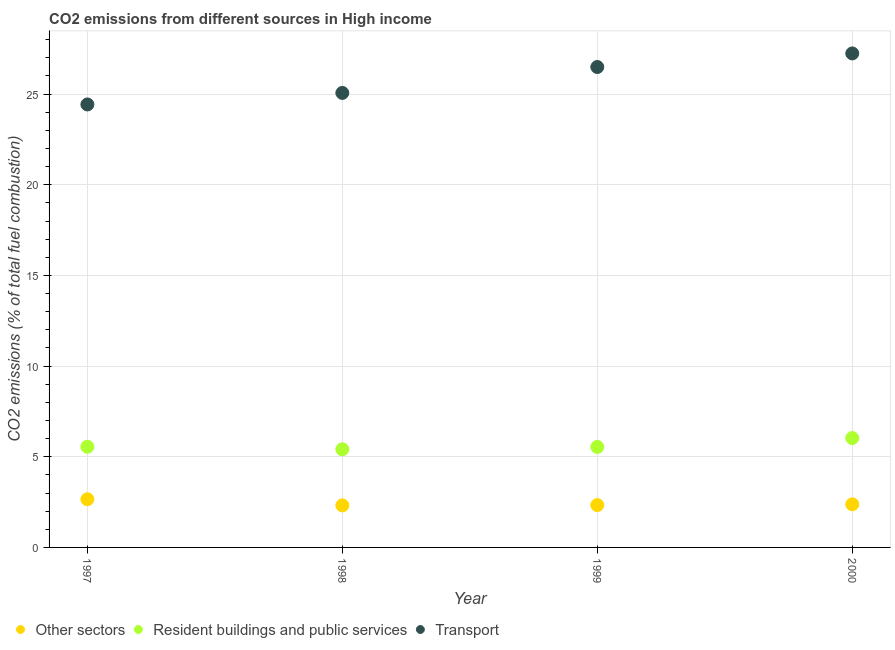Is the number of dotlines equal to the number of legend labels?
Your answer should be compact. Yes. What is the percentage of co2 emissions from transport in 1999?
Keep it short and to the point. 26.49. Across all years, what is the maximum percentage of co2 emissions from other sectors?
Give a very brief answer. 2.66. Across all years, what is the minimum percentage of co2 emissions from other sectors?
Give a very brief answer. 2.32. In which year was the percentage of co2 emissions from resident buildings and public services maximum?
Your answer should be compact. 2000. What is the total percentage of co2 emissions from resident buildings and public services in the graph?
Give a very brief answer. 22.53. What is the difference between the percentage of co2 emissions from resident buildings and public services in 1997 and that in 2000?
Make the answer very short. -0.48. What is the difference between the percentage of co2 emissions from other sectors in 1999 and the percentage of co2 emissions from transport in 1998?
Make the answer very short. -22.73. What is the average percentage of co2 emissions from resident buildings and public services per year?
Your answer should be compact. 5.63. In the year 1999, what is the difference between the percentage of co2 emissions from resident buildings and public services and percentage of co2 emissions from transport?
Provide a succinct answer. -20.95. What is the ratio of the percentage of co2 emissions from transport in 1997 to that in 1998?
Make the answer very short. 0.97. Is the percentage of co2 emissions from resident buildings and public services in 1998 less than that in 2000?
Provide a short and direct response. Yes. Is the difference between the percentage of co2 emissions from other sectors in 1998 and 1999 greater than the difference between the percentage of co2 emissions from resident buildings and public services in 1998 and 1999?
Give a very brief answer. Yes. What is the difference between the highest and the second highest percentage of co2 emissions from other sectors?
Provide a short and direct response. 0.28. What is the difference between the highest and the lowest percentage of co2 emissions from resident buildings and public services?
Ensure brevity in your answer.  0.62. Is it the case that in every year, the sum of the percentage of co2 emissions from other sectors and percentage of co2 emissions from resident buildings and public services is greater than the percentage of co2 emissions from transport?
Provide a succinct answer. No. Is the percentage of co2 emissions from transport strictly greater than the percentage of co2 emissions from resident buildings and public services over the years?
Offer a very short reply. Yes. How many years are there in the graph?
Your answer should be compact. 4. What is the difference between two consecutive major ticks on the Y-axis?
Provide a succinct answer. 5. Does the graph contain any zero values?
Your answer should be very brief. No. Does the graph contain grids?
Make the answer very short. Yes. How many legend labels are there?
Provide a succinct answer. 3. How are the legend labels stacked?
Offer a very short reply. Horizontal. What is the title of the graph?
Your answer should be very brief. CO2 emissions from different sources in High income. Does "Refusal of sex" appear as one of the legend labels in the graph?
Your response must be concise. No. What is the label or title of the Y-axis?
Provide a succinct answer. CO2 emissions (% of total fuel combustion). What is the CO2 emissions (% of total fuel combustion) in Other sectors in 1997?
Ensure brevity in your answer.  2.66. What is the CO2 emissions (% of total fuel combustion) in Resident buildings and public services in 1997?
Offer a terse response. 5.55. What is the CO2 emissions (% of total fuel combustion) in Transport in 1997?
Provide a short and direct response. 24.43. What is the CO2 emissions (% of total fuel combustion) of Other sectors in 1998?
Give a very brief answer. 2.32. What is the CO2 emissions (% of total fuel combustion) in Resident buildings and public services in 1998?
Offer a terse response. 5.41. What is the CO2 emissions (% of total fuel combustion) in Transport in 1998?
Provide a succinct answer. 25.06. What is the CO2 emissions (% of total fuel combustion) in Other sectors in 1999?
Offer a terse response. 2.33. What is the CO2 emissions (% of total fuel combustion) of Resident buildings and public services in 1999?
Ensure brevity in your answer.  5.54. What is the CO2 emissions (% of total fuel combustion) in Transport in 1999?
Keep it short and to the point. 26.49. What is the CO2 emissions (% of total fuel combustion) in Other sectors in 2000?
Your answer should be compact. 2.38. What is the CO2 emissions (% of total fuel combustion) in Resident buildings and public services in 2000?
Keep it short and to the point. 6.03. What is the CO2 emissions (% of total fuel combustion) of Transport in 2000?
Offer a terse response. 27.24. Across all years, what is the maximum CO2 emissions (% of total fuel combustion) of Other sectors?
Ensure brevity in your answer.  2.66. Across all years, what is the maximum CO2 emissions (% of total fuel combustion) in Resident buildings and public services?
Offer a very short reply. 6.03. Across all years, what is the maximum CO2 emissions (% of total fuel combustion) in Transport?
Provide a short and direct response. 27.24. Across all years, what is the minimum CO2 emissions (% of total fuel combustion) in Other sectors?
Provide a succinct answer. 2.32. Across all years, what is the minimum CO2 emissions (% of total fuel combustion) of Resident buildings and public services?
Give a very brief answer. 5.41. Across all years, what is the minimum CO2 emissions (% of total fuel combustion) of Transport?
Provide a short and direct response. 24.43. What is the total CO2 emissions (% of total fuel combustion) in Other sectors in the graph?
Keep it short and to the point. 9.69. What is the total CO2 emissions (% of total fuel combustion) in Resident buildings and public services in the graph?
Provide a short and direct response. 22.53. What is the total CO2 emissions (% of total fuel combustion) of Transport in the graph?
Provide a succinct answer. 103.22. What is the difference between the CO2 emissions (% of total fuel combustion) of Other sectors in 1997 and that in 1998?
Make the answer very short. 0.34. What is the difference between the CO2 emissions (% of total fuel combustion) in Resident buildings and public services in 1997 and that in 1998?
Provide a succinct answer. 0.14. What is the difference between the CO2 emissions (% of total fuel combustion) in Transport in 1997 and that in 1998?
Offer a terse response. -0.64. What is the difference between the CO2 emissions (% of total fuel combustion) of Other sectors in 1997 and that in 1999?
Offer a terse response. 0.32. What is the difference between the CO2 emissions (% of total fuel combustion) of Resident buildings and public services in 1997 and that in 1999?
Make the answer very short. 0.01. What is the difference between the CO2 emissions (% of total fuel combustion) in Transport in 1997 and that in 1999?
Your answer should be compact. -2.06. What is the difference between the CO2 emissions (% of total fuel combustion) of Other sectors in 1997 and that in 2000?
Keep it short and to the point. 0.28. What is the difference between the CO2 emissions (% of total fuel combustion) in Resident buildings and public services in 1997 and that in 2000?
Keep it short and to the point. -0.48. What is the difference between the CO2 emissions (% of total fuel combustion) of Transport in 1997 and that in 2000?
Give a very brief answer. -2.81. What is the difference between the CO2 emissions (% of total fuel combustion) of Other sectors in 1998 and that in 1999?
Your answer should be very brief. -0.02. What is the difference between the CO2 emissions (% of total fuel combustion) in Resident buildings and public services in 1998 and that in 1999?
Keep it short and to the point. -0.13. What is the difference between the CO2 emissions (% of total fuel combustion) in Transport in 1998 and that in 1999?
Offer a very short reply. -1.43. What is the difference between the CO2 emissions (% of total fuel combustion) in Other sectors in 1998 and that in 2000?
Make the answer very short. -0.06. What is the difference between the CO2 emissions (% of total fuel combustion) in Resident buildings and public services in 1998 and that in 2000?
Ensure brevity in your answer.  -0.62. What is the difference between the CO2 emissions (% of total fuel combustion) in Transport in 1998 and that in 2000?
Keep it short and to the point. -2.18. What is the difference between the CO2 emissions (% of total fuel combustion) in Other sectors in 1999 and that in 2000?
Your answer should be compact. -0.04. What is the difference between the CO2 emissions (% of total fuel combustion) of Resident buildings and public services in 1999 and that in 2000?
Keep it short and to the point. -0.49. What is the difference between the CO2 emissions (% of total fuel combustion) of Transport in 1999 and that in 2000?
Ensure brevity in your answer.  -0.75. What is the difference between the CO2 emissions (% of total fuel combustion) of Other sectors in 1997 and the CO2 emissions (% of total fuel combustion) of Resident buildings and public services in 1998?
Your answer should be compact. -2.75. What is the difference between the CO2 emissions (% of total fuel combustion) of Other sectors in 1997 and the CO2 emissions (% of total fuel combustion) of Transport in 1998?
Your response must be concise. -22.41. What is the difference between the CO2 emissions (% of total fuel combustion) in Resident buildings and public services in 1997 and the CO2 emissions (% of total fuel combustion) in Transport in 1998?
Your answer should be compact. -19.51. What is the difference between the CO2 emissions (% of total fuel combustion) of Other sectors in 1997 and the CO2 emissions (% of total fuel combustion) of Resident buildings and public services in 1999?
Provide a succinct answer. -2.88. What is the difference between the CO2 emissions (% of total fuel combustion) in Other sectors in 1997 and the CO2 emissions (% of total fuel combustion) in Transport in 1999?
Provide a short and direct response. -23.83. What is the difference between the CO2 emissions (% of total fuel combustion) of Resident buildings and public services in 1997 and the CO2 emissions (% of total fuel combustion) of Transport in 1999?
Provide a succinct answer. -20.94. What is the difference between the CO2 emissions (% of total fuel combustion) in Other sectors in 1997 and the CO2 emissions (% of total fuel combustion) in Resident buildings and public services in 2000?
Ensure brevity in your answer.  -3.37. What is the difference between the CO2 emissions (% of total fuel combustion) in Other sectors in 1997 and the CO2 emissions (% of total fuel combustion) in Transport in 2000?
Offer a terse response. -24.58. What is the difference between the CO2 emissions (% of total fuel combustion) of Resident buildings and public services in 1997 and the CO2 emissions (% of total fuel combustion) of Transport in 2000?
Ensure brevity in your answer.  -21.69. What is the difference between the CO2 emissions (% of total fuel combustion) of Other sectors in 1998 and the CO2 emissions (% of total fuel combustion) of Resident buildings and public services in 1999?
Offer a very short reply. -3.22. What is the difference between the CO2 emissions (% of total fuel combustion) of Other sectors in 1998 and the CO2 emissions (% of total fuel combustion) of Transport in 1999?
Ensure brevity in your answer.  -24.17. What is the difference between the CO2 emissions (% of total fuel combustion) of Resident buildings and public services in 1998 and the CO2 emissions (% of total fuel combustion) of Transport in 1999?
Keep it short and to the point. -21.08. What is the difference between the CO2 emissions (% of total fuel combustion) in Other sectors in 1998 and the CO2 emissions (% of total fuel combustion) in Resident buildings and public services in 2000?
Make the answer very short. -3.71. What is the difference between the CO2 emissions (% of total fuel combustion) in Other sectors in 1998 and the CO2 emissions (% of total fuel combustion) in Transport in 2000?
Provide a short and direct response. -24.92. What is the difference between the CO2 emissions (% of total fuel combustion) in Resident buildings and public services in 1998 and the CO2 emissions (% of total fuel combustion) in Transport in 2000?
Keep it short and to the point. -21.83. What is the difference between the CO2 emissions (% of total fuel combustion) in Other sectors in 1999 and the CO2 emissions (% of total fuel combustion) in Resident buildings and public services in 2000?
Offer a very short reply. -3.7. What is the difference between the CO2 emissions (% of total fuel combustion) in Other sectors in 1999 and the CO2 emissions (% of total fuel combustion) in Transport in 2000?
Your response must be concise. -24.91. What is the difference between the CO2 emissions (% of total fuel combustion) of Resident buildings and public services in 1999 and the CO2 emissions (% of total fuel combustion) of Transport in 2000?
Provide a succinct answer. -21.7. What is the average CO2 emissions (% of total fuel combustion) of Other sectors per year?
Your answer should be compact. 2.42. What is the average CO2 emissions (% of total fuel combustion) in Resident buildings and public services per year?
Offer a terse response. 5.63. What is the average CO2 emissions (% of total fuel combustion) in Transport per year?
Ensure brevity in your answer.  25.81. In the year 1997, what is the difference between the CO2 emissions (% of total fuel combustion) of Other sectors and CO2 emissions (% of total fuel combustion) of Resident buildings and public services?
Ensure brevity in your answer.  -2.89. In the year 1997, what is the difference between the CO2 emissions (% of total fuel combustion) of Other sectors and CO2 emissions (% of total fuel combustion) of Transport?
Your answer should be compact. -21.77. In the year 1997, what is the difference between the CO2 emissions (% of total fuel combustion) in Resident buildings and public services and CO2 emissions (% of total fuel combustion) in Transport?
Your response must be concise. -18.88. In the year 1998, what is the difference between the CO2 emissions (% of total fuel combustion) of Other sectors and CO2 emissions (% of total fuel combustion) of Resident buildings and public services?
Offer a terse response. -3.09. In the year 1998, what is the difference between the CO2 emissions (% of total fuel combustion) in Other sectors and CO2 emissions (% of total fuel combustion) in Transport?
Offer a terse response. -22.74. In the year 1998, what is the difference between the CO2 emissions (% of total fuel combustion) in Resident buildings and public services and CO2 emissions (% of total fuel combustion) in Transport?
Give a very brief answer. -19.65. In the year 1999, what is the difference between the CO2 emissions (% of total fuel combustion) of Other sectors and CO2 emissions (% of total fuel combustion) of Resident buildings and public services?
Offer a terse response. -3.21. In the year 1999, what is the difference between the CO2 emissions (% of total fuel combustion) in Other sectors and CO2 emissions (% of total fuel combustion) in Transport?
Your answer should be very brief. -24.16. In the year 1999, what is the difference between the CO2 emissions (% of total fuel combustion) in Resident buildings and public services and CO2 emissions (% of total fuel combustion) in Transport?
Provide a succinct answer. -20.95. In the year 2000, what is the difference between the CO2 emissions (% of total fuel combustion) in Other sectors and CO2 emissions (% of total fuel combustion) in Resident buildings and public services?
Your response must be concise. -3.65. In the year 2000, what is the difference between the CO2 emissions (% of total fuel combustion) in Other sectors and CO2 emissions (% of total fuel combustion) in Transport?
Offer a terse response. -24.86. In the year 2000, what is the difference between the CO2 emissions (% of total fuel combustion) of Resident buildings and public services and CO2 emissions (% of total fuel combustion) of Transport?
Your answer should be compact. -21.21. What is the ratio of the CO2 emissions (% of total fuel combustion) of Other sectors in 1997 to that in 1998?
Your answer should be compact. 1.15. What is the ratio of the CO2 emissions (% of total fuel combustion) of Resident buildings and public services in 1997 to that in 1998?
Provide a short and direct response. 1.03. What is the ratio of the CO2 emissions (% of total fuel combustion) of Transport in 1997 to that in 1998?
Your answer should be very brief. 0.97. What is the ratio of the CO2 emissions (% of total fuel combustion) of Other sectors in 1997 to that in 1999?
Your response must be concise. 1.14. What is the ratio of the CO2 emissions (% of total fuel combustion) in Resident buildings and public services in 1997 to that in 1999?
Your response must be concise. 1. What is the ratio of the CO2 emissions (% of total fuel combustion) of Transport in 1997 to that in 1999?
Give a very brief answer. 0.92. What is the ratio of the CO2 emissions (% of total fuel combustion) in Other sectors in 1997 to that in 2000?
Make the answer very short. 1.12. What is the ratio of the CO2 emissions (% of total fuel combustion) of Resident buildings and public services in 1997 to that in 2000?
Your answer should be compact. 0.92. What is the ratio of the CO2 emissions (% of total fuel combustion) in Transport in 1997 to that in 2000?
Provide a short and direct response. 0.9. What is the ratio of the CO2 emissions (% of total fuel combustion) in Resident buildings and public services in 1998 to that in 1999?
Your answer should be very brief. 0.98. What is the ratio of the CO2 emissions (% of total fuel combustion) of Transport in 1998 to that in 1999?
Offer a terse response. 0.95. What is the ratio of the CO2 emissions (% of total fuel combustion) in Other sectors in 1998 to that in 2000?
Give a very brief answer. 0.98. What is the ratio of the CO2 emissions (% of total fuel combustion) of Resident buildings and public services in 1998 to that in 2000?
Provide a succinct answer. 0.9. What is the ratio of the CO2 emissions (% of total fuel combustion) in Transport in 1998 to that in 2000?
Give a very brief answer. 0.92. What is the ratio of the CO2 emissions (% of total fuel combustion) of Other sectors in 1999 to that in 2000?
Ensure brevity in your answer.  0.98. What is the ratio of the CO2 emissions (% of total fuel combustion) of Resident buildings and public services in 1999 to that in 2000?
Your answer should be compact. 0.92. What is the ratio of the CO2 emissions (% of total fuel combustion) of Transport in 1999 to that in 2000?
Your answer should be compact. 0.97. What is the difference between the highest and the second highest CO2 emissions (% of total fuel combustion) in Other sectors?
Keep it short and to the point. 0.28. What is the difference between the highest and the second highest CO2 emissions (% of total fuel combustion) of Resident buildings and public services?
Keep it short and to the point. 0.48. What is the difference between the highest and the second highest CO2 emissions (% of total fuel combustion) in Transport?
Offer a very short reply. 0.75. What is the difference between the highest and the lowest CO2 emissions (% of total fuel combustion) in Other sectors?
Offer a very short reply. 0.34. What is the difference between the highest and the lowest CO2 emissions (% of total fuel combustion) of Resident buildings and public services?
Offer a terse response. 0.62. What is the difference between the highest and the lowest CO2 emissions (% of total fuel combustion) in Transport?
Ensure brevity in your answer.  2.81. 